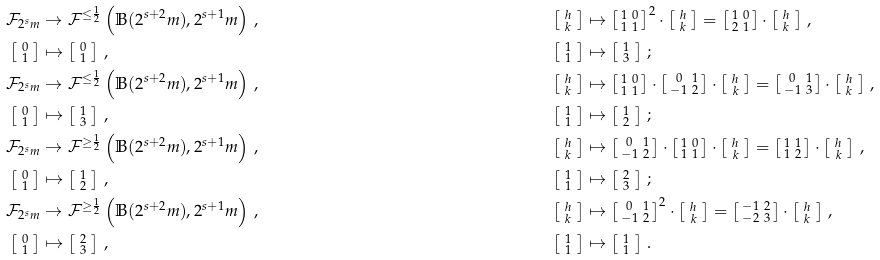Convert formula to latex. <formula><loc_0><loc_0><loc_500><loc_500>\mathcal { F } _ { 2 ^ { s } m } & \to \mathcal { F } ^ { \leq \frac { 1 } { 2 } } \left ( \mathbb { B } ( 2 ^ { s + 2 } m ) , 2 ^ { s + 1 } m \right ) \, , & \left [ \begin{smallmatrix} \, h \, \\ \, k \, \end{smallmatrix} \right ] & \mapsto \left [ \begin{smallmatrix} 1 & 0 \\ 1 & 1 \end{smallmatrix} \right ] ^ { 2 } \cdot \left [ \begin{smallmatrix} \, h \, \\ \, k \, \end{smallmatrix} \right ] = \left [ \begin{smallmatrix} 1 & 0 \\ 2 & 1 \end{smallmatrix} \right ] \cdot \left [ \begin{smallmatrix} \, h \, \\ \, k \, \end{smallmatrix} \right ] \, , \\ \left [ \begin{smallmatrix} \, 0 \, \\ \, 1 \, \end{smallmatrix} \right ] & \mapsto \left [ \begin{smallmatrix} \, 0 \, \\ \, 1 \, \end{smallmatrix} \right ] \, , & \left [ \begin{smallmatrix} \, 1 \, \\ \, 1 \, \end{smallmatrix} \right ] & \mapsto \left [ \begin{smallmatrix} \, 1 \, \\ \, 3 \, \end{smallmatrix} \right ] \, ; \\ \mathcal { F } _ { 2 ^ { s } m } & \to \mathcal { F } ^ { \leq \frac { 1 } { 2 } } \left ( \mathbb { B } ( 2 ^ { s + 2 } m ) , 2 ^ { s + 1 } m \right ) \, , & \left [ \begin{smallmatrix} \, h \, \\ \, k \, \end{smallmatrix} \right ] & \mapsto \left [ \begin{smallmatrix} 1 & 0 \\ 1 & 1 \end{smallmatrix} \right ] \cdot \left [ \begin{smallmatrix} 0 & 1 \\ - 1 & 2 \end{smallmatrix} \right ] \cdot \left [ \begin{smallmatrix} \, h \, \\ \, k \, \end{smallmatrix} \right ] = \left [ \begin{smallmatrix} 0 & 1 \\ - 1 & 3 \end{smallmatrix} \right ] \cdot \left [ \begin{smallmatrix} \, h \, \\ \, k \, \end{smallmatrix} \right ] \, , \\ \left [ \begin{smallmatrix} \, 0 \, \\ \, 1 \, \end{smallmatrix} \right ] & \mapsto \left [ \begin{smallmatrix} \, 1 \, \\ \, 3 \, \end{smallmatrix} \right ] \, , & \left [ \begin{smallmatrix} \, 1 \, \\ \, 1 \, \end{smallmatrix} \right ] & \mapsto \left [ \begin{smallmatrix} \, 1 \, \\ \, 2 \, \end{smallmatrix} \right ] \, ; \\ \mathcal { F } _ { 2 ^ { s } m } & \to \mathcal { F } ^ { \geq \frac { 1 } { 2 } } \left ( \mathbb { B } ( 2 ^ { s + 2 } m ) , 2 ^ { s + 1 } m \right ) \, , & \left [ \begin{smallmatrix} \, h \, \\ \, k \, \end{smallmatrix} \right ] & \mapsto \left [ \begin{smallmatrix} 0 & 1 \\ - 1 & 2 \end{smallmatrix} \right ] \cdot \left [ \begin{smallmatrix} 1 & 0 \\ 1 & 1 \end{smallmatrix} \right ] \cdot \left [ \begin{smallmatrix} \, h \, \\ \, k \, \end{smallmatrix} \right ] = \left [ \begin{smallmatrix} 1 & 1 \\ 1 & 2 \end{smallmatrix} \right ] \cdot \left [ \begin{smallmatrix} \, h \, \\ \, k \, \end{smallmatrix} \right ] \, , \\ \left [ \begin{smallmatrix} \, 0 \, \\ \, 1 \, \end{smallmatrix} \right ] & \mapsto \left [ \begin{smallmatrix} \, 1 \, \\ \, 2 \, \end{smallmatrix} \right ] \, , & \left [ \begin{smallmatrix} \, 1 \, \\ \, 1 \, \end{smallmatrix} \right ] & \mapsto \left [ \begin{smallmatrix} \, 2 \, \\ \, 3 \, \end{smallmatrix} \right ] \, ; \\ \mathcal { F } _ { 2 ^ { s } m } & \to \mathcal { F } ^ { \geq \frac { 1 } { 2 } } \left ( \mathbb { B } ( 2 ^ { s + 2 } m ) , 2 ^ { s + 1 } m \right ) \, , & \left [ \begin{smallmatrix} \, h \, \\ \, k \, \end{smallmatrix} \right ] & \mapsto \left [ \begin{smallmatrix} 0 & 1 \\ - 1 & 2 \end{smallmatrix} \right ] ^ { 2 } \cdot \left [ \begin{smallmatrix} \, h \, \\ \, k \, \end{smallmatrix} \right ] = \left [ \begin{smallmatrix} - 1 & 2 \\ - 2 & 3 \end{smallmatrix} \right ] \cdot \left [ \begin{smallmatrix} \, h \, \\ \, k \, \end{smallmatrix} \right ] \, , \\ \left [ \begin{smallmatrix} \, 0 \, \\ \, 1 \, \end{smallmatrix} \right ] & \mapsto \left [ \begin{smallmatrix} \, 2 \, \\ \, 3 \, \end{smallmatrix} \right ] \, , & \left [ \begin{smallmatrix} \, 1 \, \\ \, 1 \, \end{smallmatrix} \right ] & \mapsto \left [ \begin{smallmatrix} \, 1 \, \\ \, 1 \, \end{smallmatrix} \right ] \, .</formula> 